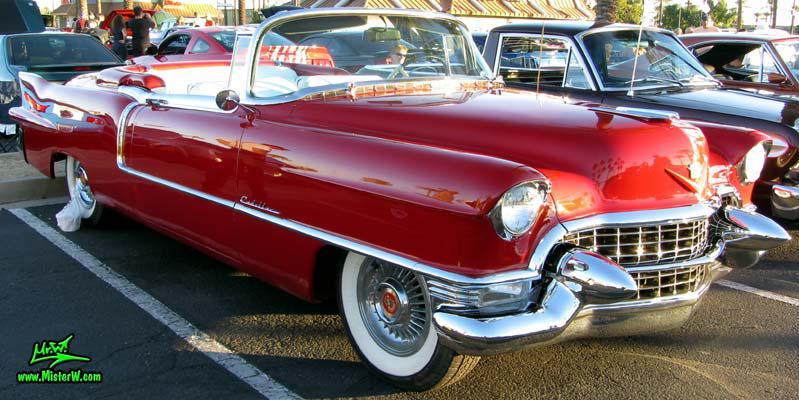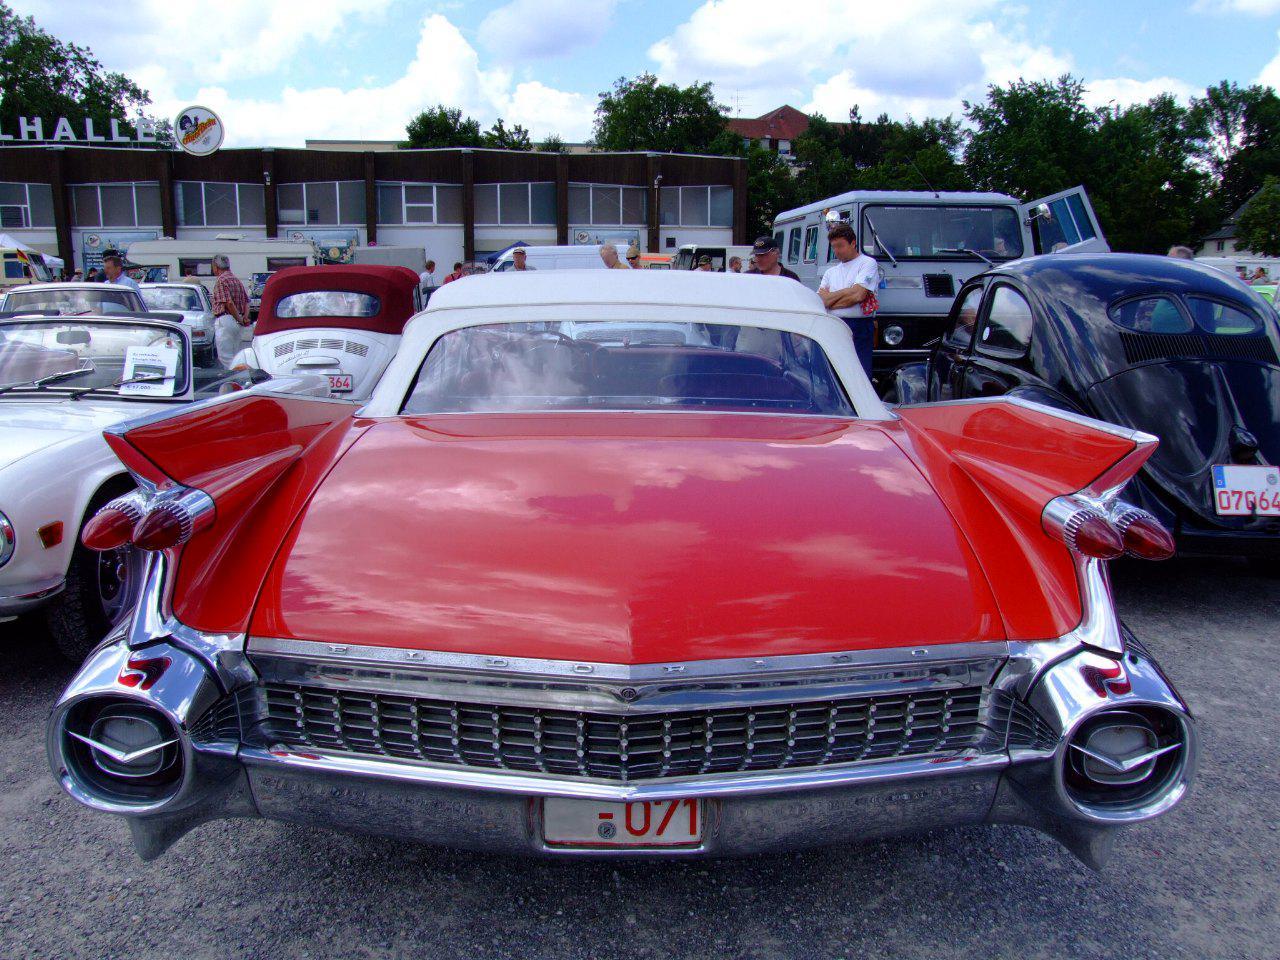The first image is the image on the left, the second image is the image on the right. For the images shown, is this caption "One image shows a red soft-topped vintage car with missile-like red lights and jutting fins, and the other image shows a red topless vintage convertible." true? Answer yes or no. Yes. The first image is the image on the left, the second image is the image on the right. For the images shown, is this caption "The car in the image on the left has its top up." true? Answer yes or no. No. 